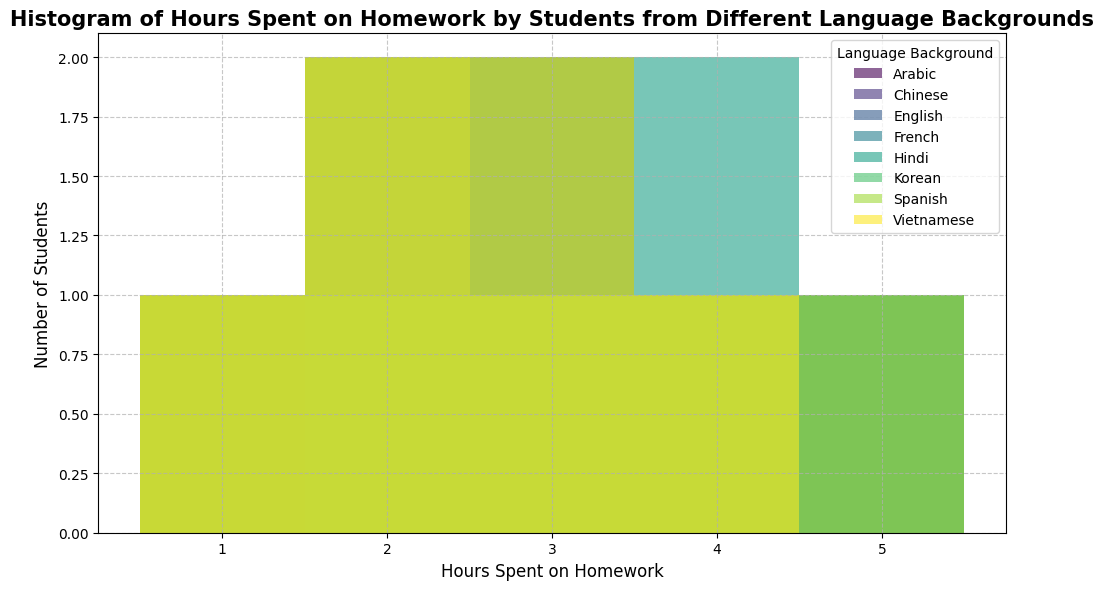What is the most common number of hours spent on homework by French-speaking students? Look for the highest bar in the histogram labeled under "French" to see which number of hours has the most students.
Answer: 3 How many more students spent 4 hours on homework compared to 1 hour for Hindi speakers? Find the heights of bars for 4 hours and 1 hour under "Hindi". Subtract the height of the 1-hour bar from the height of the 4-hour bar.
Answer: 3 Which language group has the highest single peak in the histogram? Identify which histogram bar reaches the highest point across all language groups.
Answer: French How many students spent more than 3 hours on homework in the Spanish-speaking group? Sum the heights of the bars above 3 hours in the Spanish section (4 hours and 5 hours).
Answer: 2 What is the average number of hours spent on homework by the Korean-speaking group? Calculate the total hours from the histogram bars (e.g., 1 student * 1 hour + 1 student * 2 hours + 2 students * 3 hours + 1 student * 4 hours + 1 student * 5 hours) and divide by the total number of students.
Answer: 3 Which language background has the most students who spent exactly 2 hours on homework? Look for the bar corresponding to 2 hours across all language groups and identify the language group with the highest one.
Answer: Vietnamese Is the distribution of English speakers' homework hours more spread out compared to Arabic speakers? Compare the range and the spread of the heights of the bars for "English" and "Arabic".
Answer: Yes How many Chinese-speaking students spent at least 3 hours on homework? Sum the number of students at 3 hours, 4 hours, and 5 hours for the Chinese category in the histogram.
Answer: 4 Which language group has the most even distribution of students across different hours? Look for the language group where the bars have similar heights, indicating an even distribution.
Answer: Hindi 